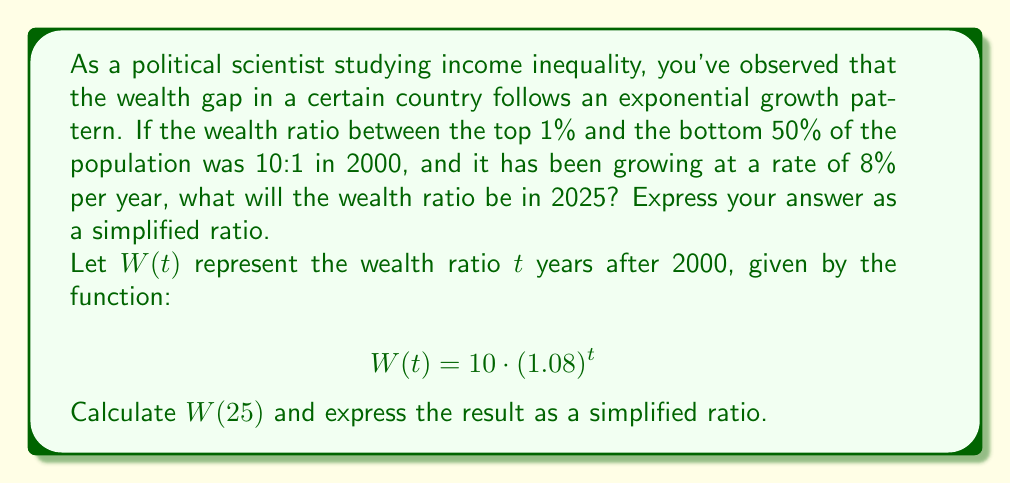Give your solution to this math problem. To solve this problem, we need to follow these steps:

1) We're given the exponential function for the wealth ratio:
   $$W(t) = 10 \cdot (1.08)^t$$
   Where $t$ is the number of years since 2000.

2) We need to calculate $W(25)$ because 2025 is 25 years after 2000:
   $$W(25) = 10 \cdot (1.08)^{25}$$

3) Let's calculate this:
   $$\begin{align}
   W(25) &= 10 \cdot (1.08)^{25} \\
   &= 10 \cdot 6.848 \\
   &= 68.48
   \end{align}$$

4) This means that in 2025, the wealth ratio between the top 1% and the bottom 50% will be 68.48:1.

5) To express this as a simplified ratio, we can round to the nearest whole number:
   68:1

This result indicates a significant increase in wealth inequality over the 25-year period, with the gap between the richest 1% and the bottom 50% growing from 10:1 to approximately 68:1.
Answer: 68:1 